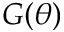<formula> <loc_0><loc_0><loc_500><loc_500>G ( \theta )</formula> 